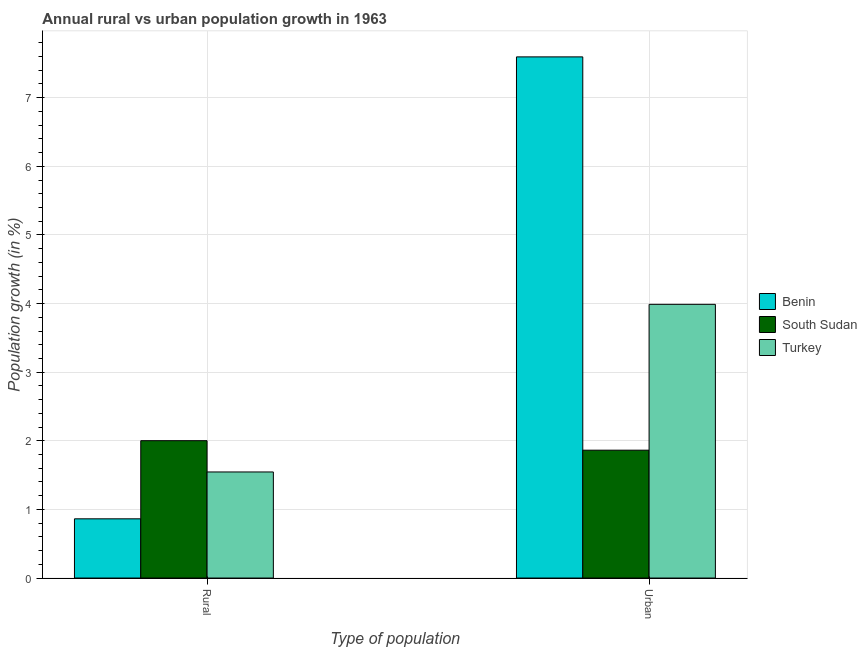Are the number of bars per tick equal to the number of legend labels?
Make the answer very short. Yes. How many bars are there on the 1st tick from the left?
Your answer should be compact. 3. What is the label of the 2nd group of bars from the left?
Make the answer very short. Urban . What is the urban population growth in South Sudan?
Provide a short and direct response. 1.86. Across all countries, what is the maximum rural population growth?
Make the answer very short. 2. Across all countries, what is the minimum rural population growth?
Offer a very short reply. 0.86. In which country was the rural population growth maximum?
Make the answer very short. South Sudan. In which country was the rural population growth minimum?
Offer a terse response. Benin. What is the total urban population growth in the graph?
Provide a short and direct response. 13.45. What is the difference between the urban population growth in Turkey and that in South Sudan?
Make the answer very short. 2.13. What is the difference between the urban population growth in South Sudan and the rural population growth in Benin?
Your answer should be very brief. 1. What is the average urban population growth per country?
Provide a succinct answer. 4.48. What is the difference between the urban population growth and rural population growth in Benin?
Ensure brevity in your answer.  6.73. What is the ratio of the urban population growth in Turkey to that in Benin?
Your response must be concise. 0.53. In how many countries, is the urban population growth greater than the average urban population growth taken over all countries?
Make the answer very short. 1. What does the 2nd bar from the right in Urban  represents?
Provide a short and direct response. South Sudan. How many countries are there in the graph?
Give a very brief answer. 3. Does the graph contain any zero values?
Your response must be concise. No. Where does the legend appear in the graph?
Offer a very short reply. Center right. How many legend labels are there?
Keep it short and to the point. 3. What is the title of the graph?
Provide a succinct answer. Annual rural vs urban population growth in 1963. Does "Kuwait" appear as one of the legend labels in the graph?
Make the answer very short. No. What is the label or title of the X-axis?
Offer a very short reply. Type of population. What is the label or title of the Y-axis?
Provide a short and direct response. Population growth (in %). What is the Population growth (in %) of Benin in Rural?
Provide a succinct answer. 0.86. What is the Population growth (in %) of South Sudan in Rural?
Keep it short and to the point. 2. What is the Population growth (in %) of Turkey in Rural?
Provide a short and direct response. 1.55. What is the Population growth (in %) of Benin in Urban ?
Ensure brevity in your answer.  7.59. What is the Population growth (in %) of South Sudan in Urban ?
Make the answer very short. 1.86. What is the Population growth (in %) of Turkey in Urban ?
Make the answer very short. 3.99. Across all Type of population, what is the maximum Population growth (in %) of Benin?
Provide a succinct answer. 7.59. Across all Type of population, what is the maximum Population growth (in %) in South Sudan?
Keep it short and to the point. 2. Across all Type of population, what is the maximum Population growth (in %) of Turkey?
Offer a very short reply. 3.99. Across all Type of population, what is the minimum Population growth (in %) of Benin?
Make the answer very short. 0.86. Across all Type of population, what is the minimum Population growth (in %) in South Sudan?
Offer a terse response. 1.86. Across all Type of population, what is the minimum Population growth (in %) in Turkey?
Keep it short and to the point. 1.55. What is the total Population growth (in %) of Benin in the graph?
Offer a terse response. 8.46. What is the total Population growth (in %) in South Sudan in the graph?
Ensure brevity in your answer.  3.87. What is the total Population growth (in %) in Turkey in the graph?
Keep it short and to the point. 5.53. What is the difference between the Population growth (in %) in Benin in Rural and that in Urban ?
Make the answer very short. -6.73. What is the difference between the Population growth (in %) in South Sudan in Rural and that in Urban ?
Your response must be concise. 0.14. What is the difference between the Population growth (in %) of Turkey in Rural and that in Urban ?
Offer a very short reply. -2.44. What is the difference between the Population growth (in %) in Benin in Rural and the Population growth (in %) in South Sudan in Urban?
Provide a short and direct response. -1. What is the difference between the Population growth (in %) in Benin in Rural and the Population growth (in %) in Turkey in Urban?
Ensure brevity in your answer.  -3.13. What is the difference between the Population growth (in %) in South Sudan in Rural and the Population growth (in %) in Turkey in Urban?
Offer a terse response. -1.99. What is the average Population growth (in %) in Benin per Type of population?
Make the answer very short. 4.23. What is the average Population growth (in %) in South Sudan per Type of population?
Your answer should be very brief. 1.93. What is the average Population growth (in %) of Turkey per Type of population?
Your answer should be compact. 2.77. What is the difference between the Population growth (in %) of Benin and Population growth (in %) of South Sudan in Rural?
Provide a short and direct response. -1.14. What is the difference between the Population growth (in %) of Benin and Population growth (in %) of Turkey in Rural?
Your answer should be compact. -0.68. What is the difference between the Population growth (in %) in South Sudan and Population growth (in %) in Turkey in Rural?
Keep it short and to the point. 0.46. What is the difference between the Population growth (in %) in Benin and Population growth (in %) in South Sudan in Urban ?
Offer a terse response. 5.73. What is the difference between the Population growth (in %) of Benin and Population growth (in %) of Turkey in Urban ?
Make the answer very short. 3.61. What is the difference between the Population growth (in %) in South Sudan and Population growth (in %) in Turkey in Urban ?
Give a very brief answer. -2.13. What is the ratio of the Population growth (in %) of Benin in Rural to that in Urban ?
Your answer should be very brief. 0.11. What is the ratio of the Population growth (in %) of South Sudan in Rural to that in Urban ?
Make the answer very short. 1.07. What is the ratio of the Population growth (in %) in Turkey in Rural to that in Urban ?
Make the answer very short. 0.39. What is the difference between the highest and the second highest Population growth (in %) in Benin?
Provide a succinct answer. 6.73. What is the difference between the highest and the second highest Population growth (in %) in South Sudan?
Offer a terse response. 0.14. What is the difference between the highest and the second highest Population growth (in %) of Turkey?
Provide a succinct answer. 2.44. What is the difference between the highest and the lowest Population growth (in %) of Benin?
Ensure brevity in your answer.  6.73. What is the difference between the highest and the lowest Population growth (in %) in South Sudan?
Offer a very short reply. 0.14. What is the difference between the highest and the lowest Population growth (in %) in Turkey?
Ensure brevity in your answer.  2.44. 